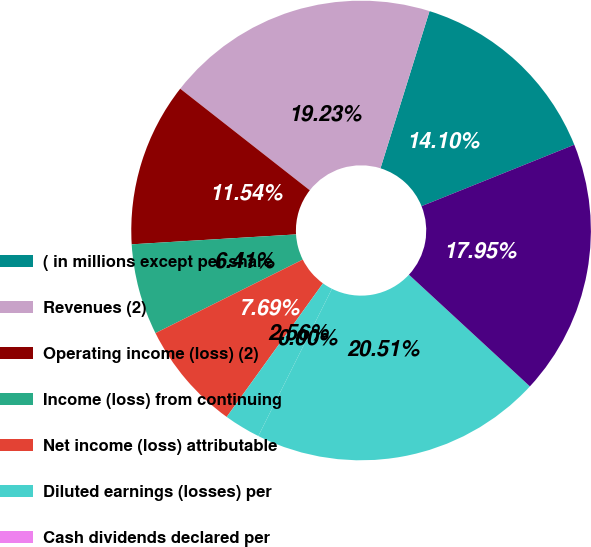Convert chart. <chart><loc_0><loc_0><loc_500><loc_500><pie_chart><fcel>( in millions except per share<fcel>Revenues (2)<fcel>Operating income (loss) (2)<fcel>Income (loss) from continuing<fcel>Net income (loss) attributable<fcel>Diluted earnings (losses) per<fcel>Cash dividends declared per<fcel>Total assets (7)<fcel>Long-term debt (7)<nl><fcel>14.1%<fcel>19.23%<fcel>11.54%<fcel>6.41%<fcel>7.69%<fcel>2.56%<fcel>0.0%<fcel>20.51%<fcel>17.95%<nl></chart> 